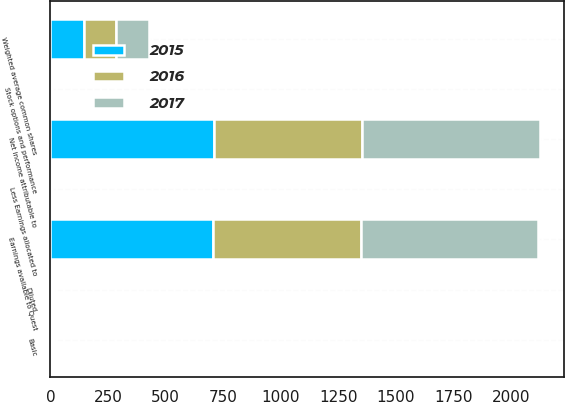Convert chart. <chart><loc_0><loc_0><loc_500><loc_500><stacked_bar_chart><ecel><fcel>Net income attributable to<fcel>Less Earnings allocated to<fcel>Earnings available to Quest<fcel>Weighted average common shares<fcel>Stock options and performance<fcel>Basic<fcel>Diluted<nl><fcel>2017<fcel>772<fcel>3<fcel>769<fcel>140<fcel>3<fcel>5.63<fcel>5.5<nl><fcel>2016<fcel>645<fcel>3<fcel>642<fcel>142<fcel>2<fcel>4.58<fcel>4.51<nl><fcel>2015<fcel>709<fcel>3<fcel>706<fcel>145<fcel>1<fcel>4.92<fcel>4.87<nl></chart> 